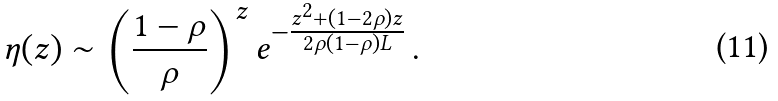Convert formula to latex. <formula><loc_0><loc_0><loc_500><loc_500>\eta ( z ) \sim \left ( \frac { 1 - \rho } { \rho } \right ) ^ { z } e ^ { - \frac { z ^ { 2 } + ( 1 - 2 \rho ) z } { 2 \rho ( 1 - \rho ) L } } \, .</formula> 